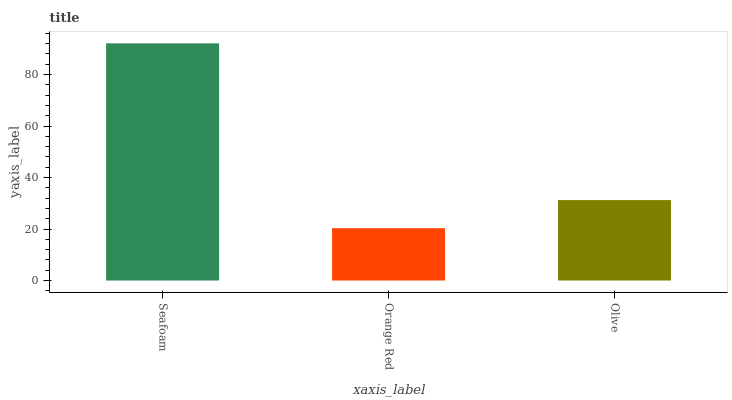Is Olive the minimum?
Answer yes or no. No. Is Olive the maximum?
Answer yes or no. No. Is Olive greater than Orange Red?
Answer yes or no. Yes. Is Orange Red less than Olive?
Answer yes or no. Yes. Is Orange Red greater than Olive?
Answer yes or no. No. Is Olive less than Orange Red?
Answer yes or no. No. Is Olive the high median?
Answer yes or no. Yes. Is Olive the low median?
Answer yes or no. Yes. Is Seafoam the high median?
Answer yes or no. No. Is Orange Red the low median?
Answer yes or no. No. 